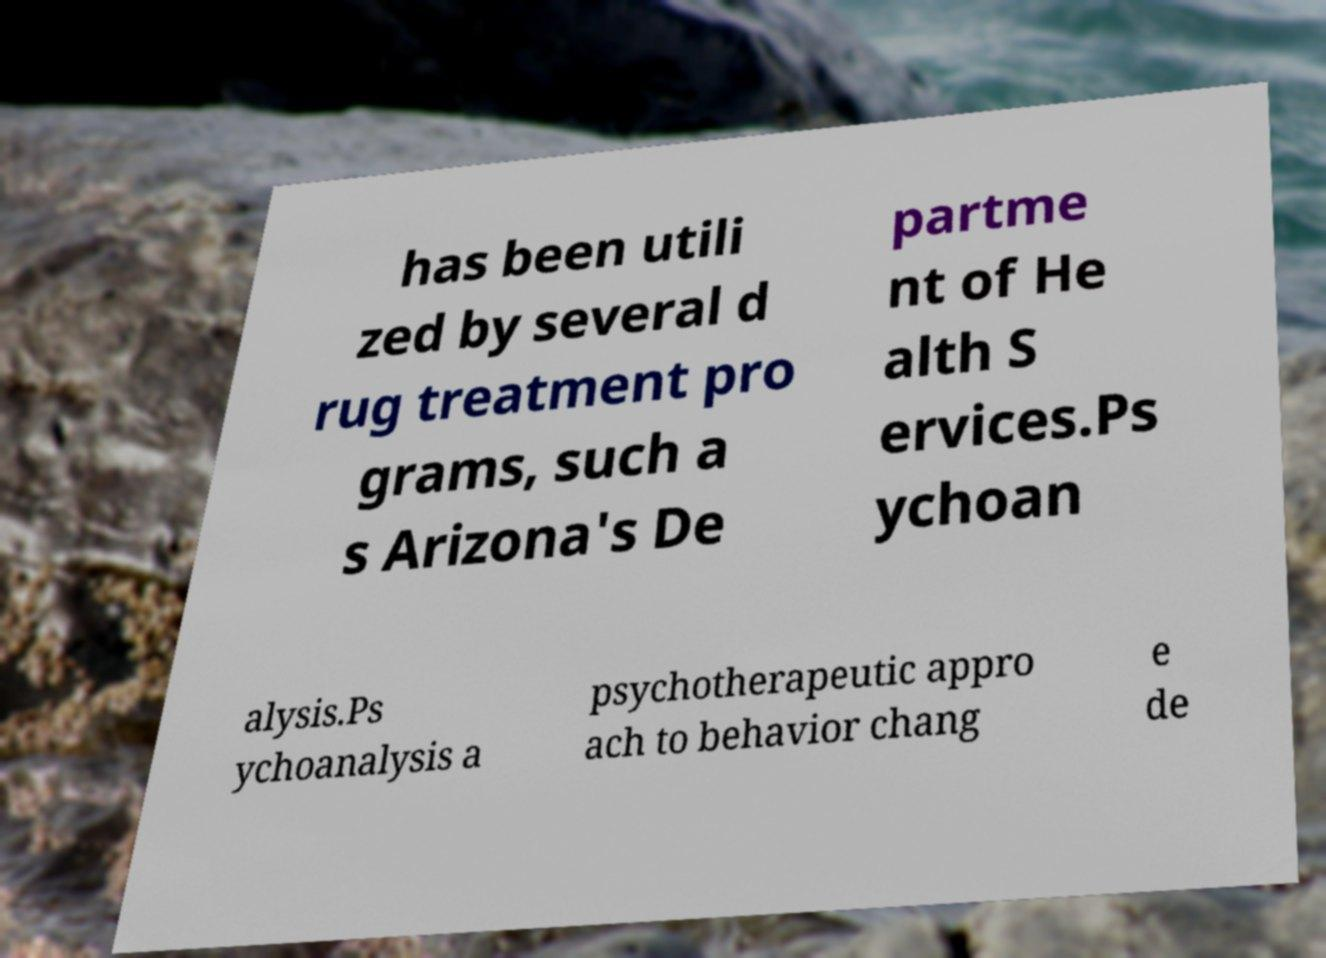Could you extract and type out the text from this image? has been utili zed by several d rug treatment pro grams, such a s Arizona's De partme nt of He alth S ervices.Ps ychoan alysis.Ps ychoanalysis a psychotherapeutic appro ach to behavior chang e de 